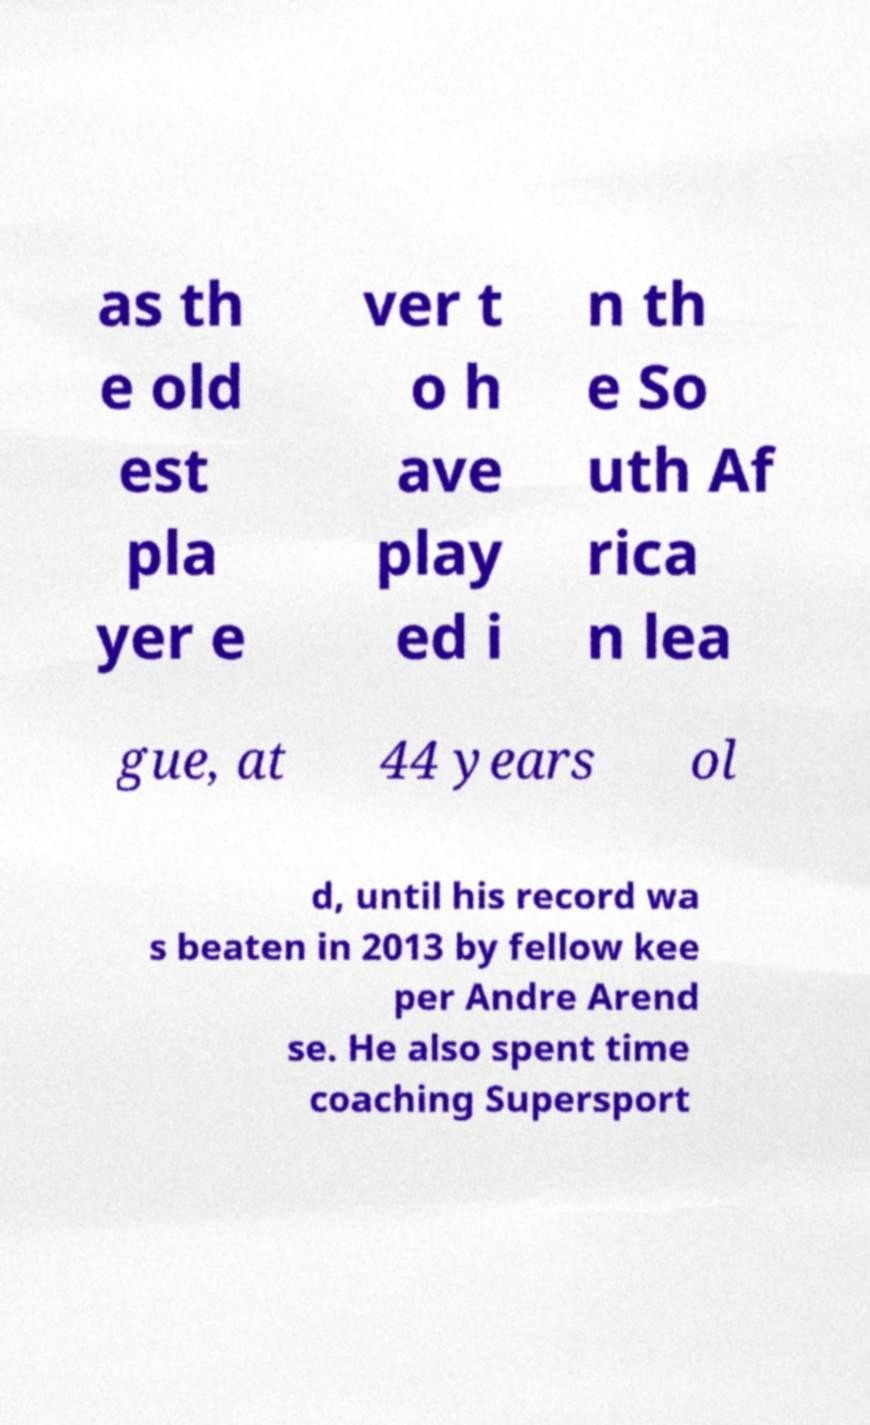What messages or text are displayed in this image? I need them in a readable, typed format. as th e old est pla yer e ver t o h ave play ed i n th e So uth Af rica n lea gue, at 44 years ol d, until his record wa s beaten in 2013 by fellow kee per Andre Arend se. He also spent time coaching Supersport 